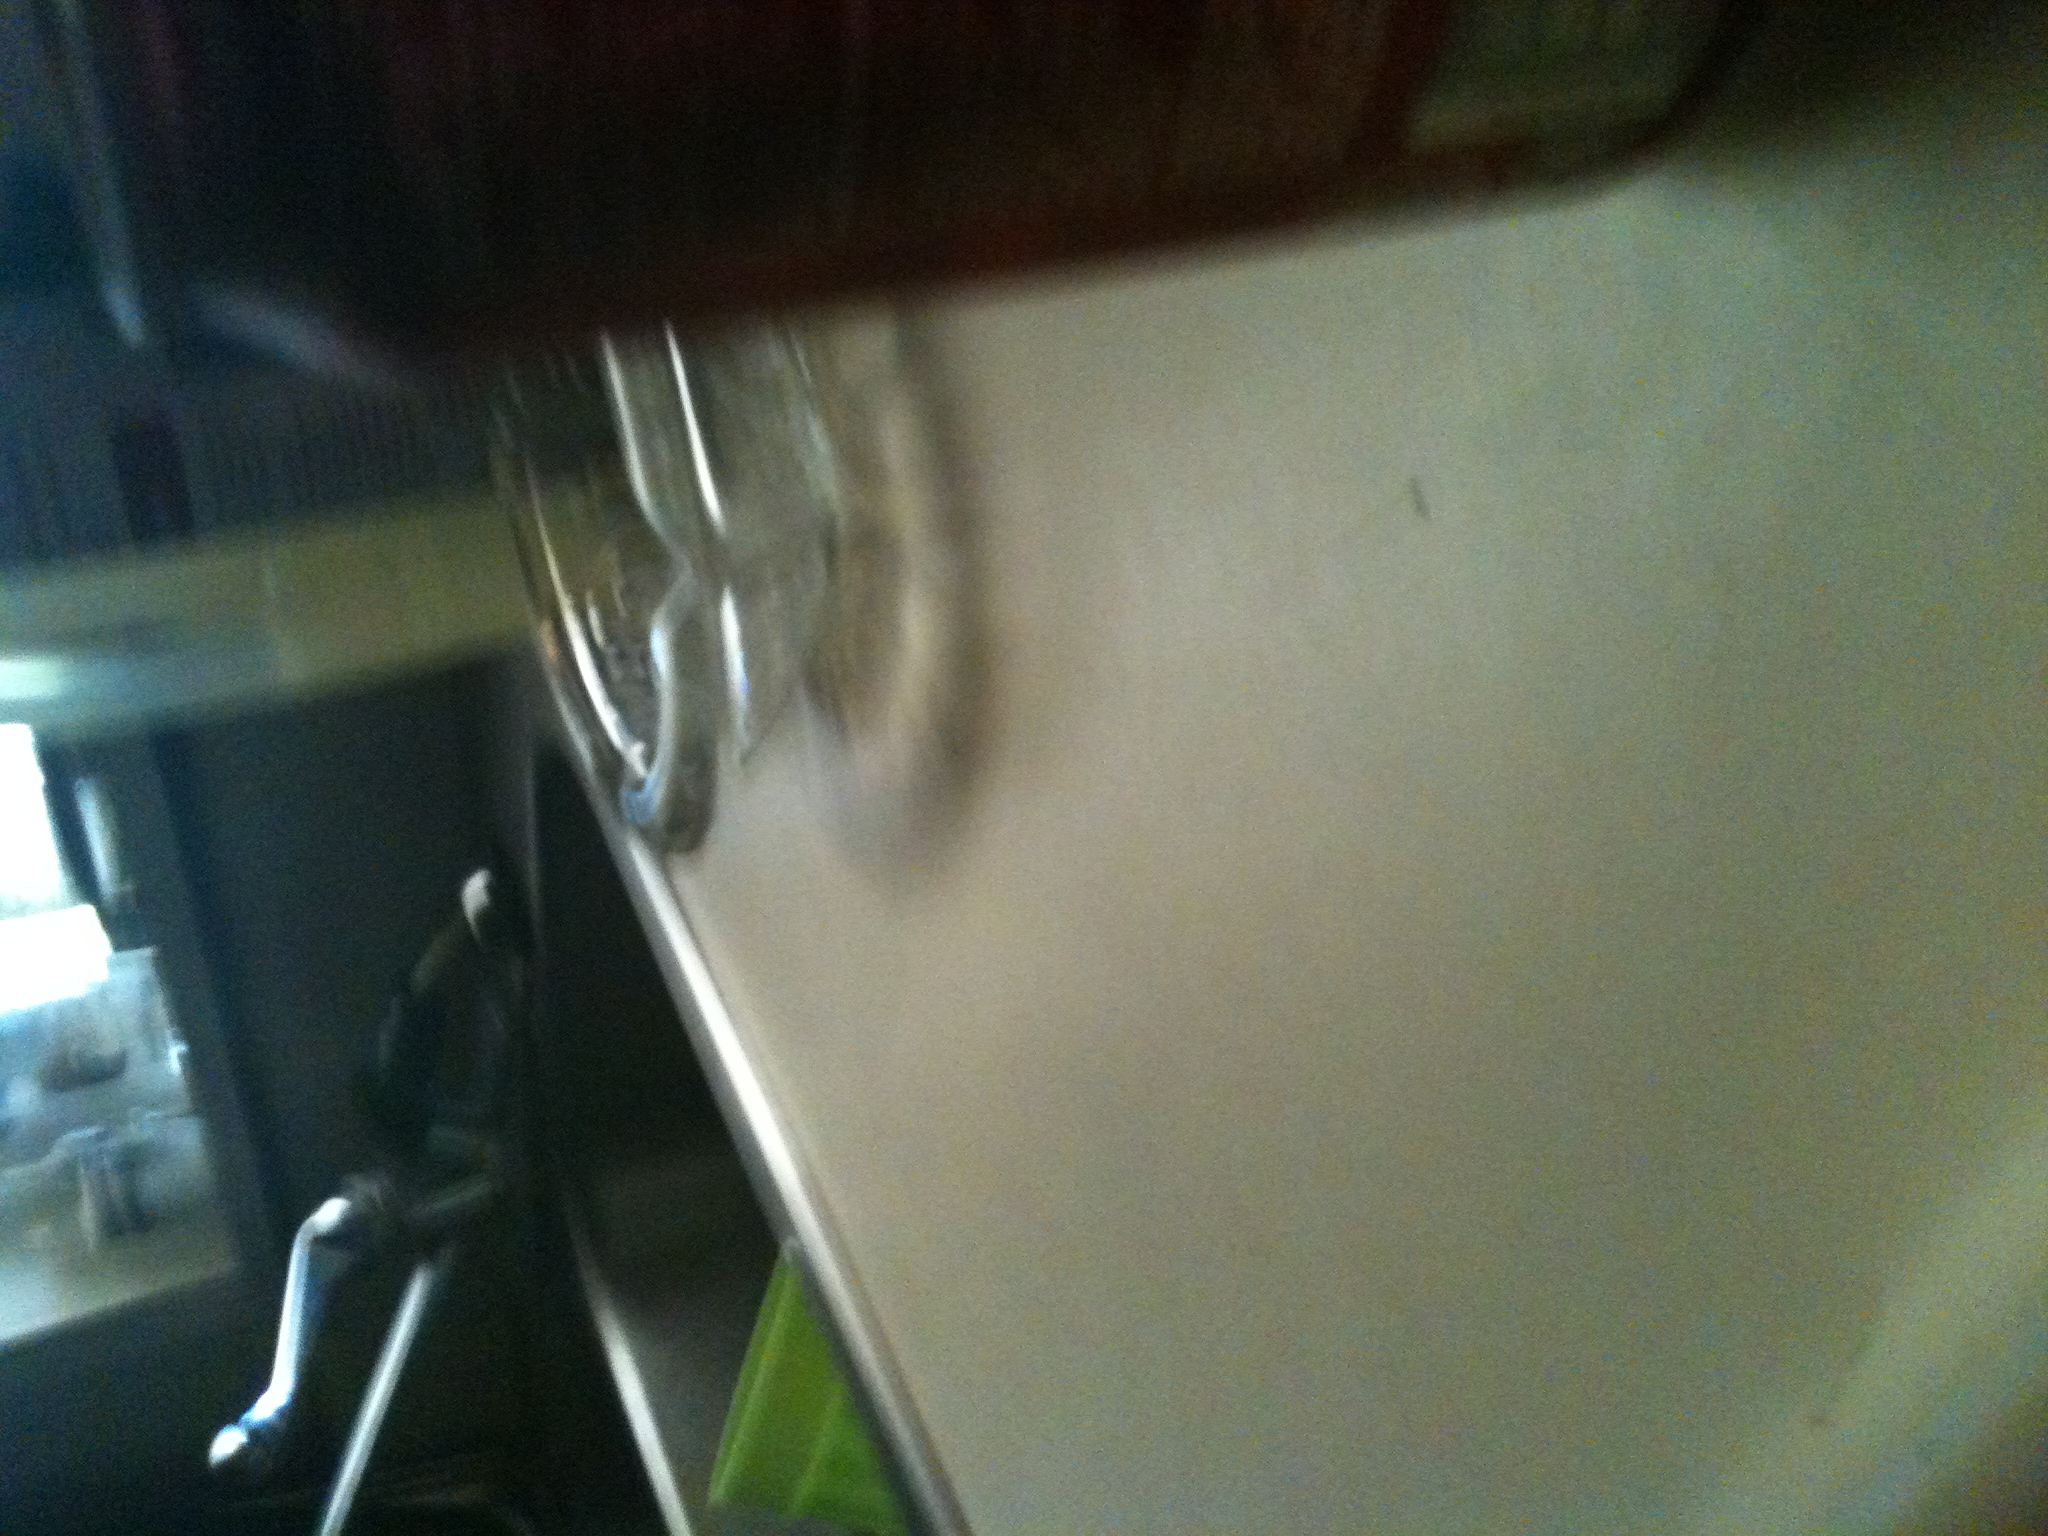Can you tell me what drink this is? It's difficult to make out specific details because the image is blurry and the focus is unclear. However, one can observe a red can which may possibly be a soda can, often seen with popular beverages. Without clearer visual information, it's impossible to specify the exact drink. 